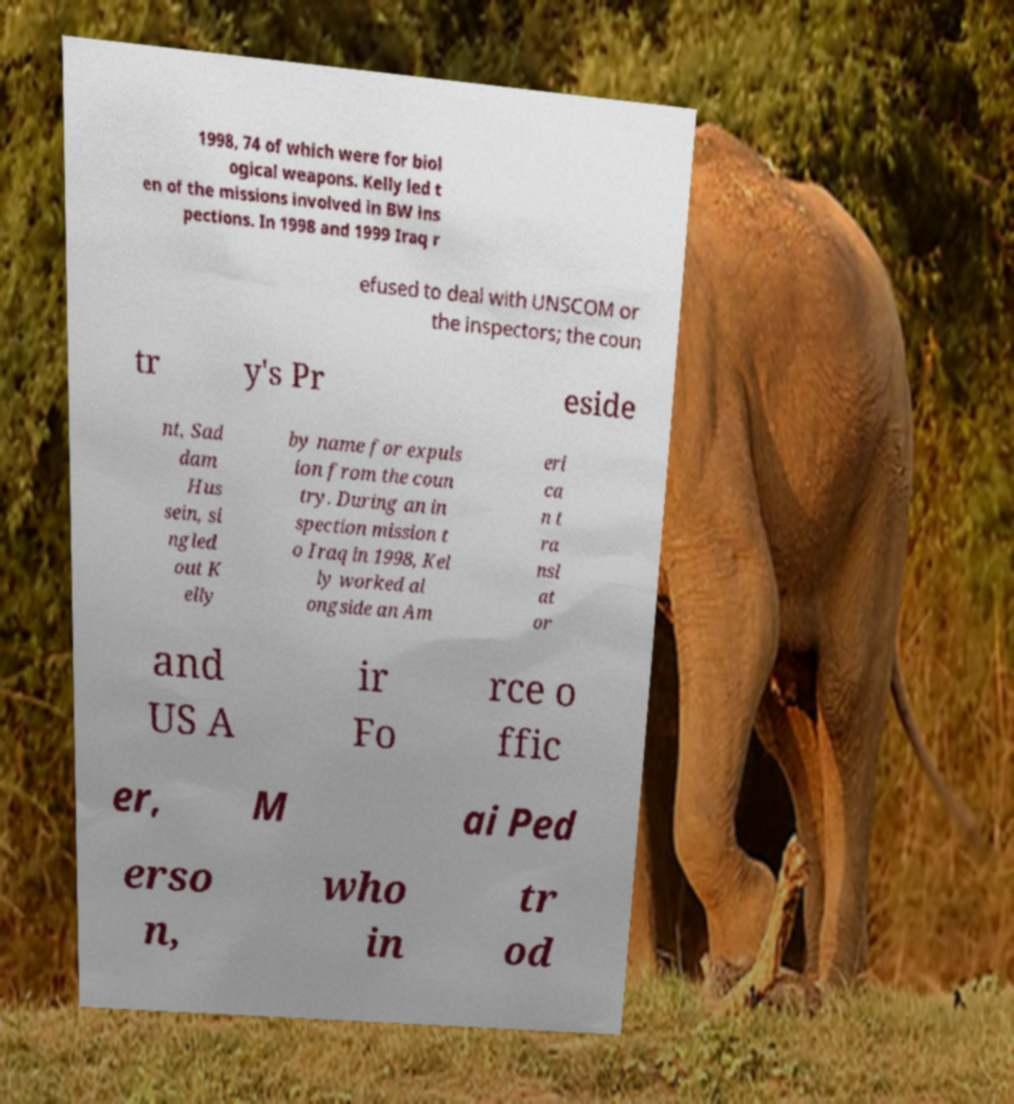For documentation purposes, I need the text within this image transcribed. Could you provide that? 1998, 74 of which were for biol ogical weapons. Kelly led t en of the missions involved in BW ins pections. In 1998 and 1999 Iraq r efused to deal with UNSCOM or the inspectors; the coun tr y's Pr eside nt, Sad dam Hus sein, si ngled out K elly by name for expuls ion from the coun try. During an in spection mission t o Iraq in 1998, Kel ly worked al ongside an Am eri ca n t ra nsl at or and US A ir Fo rce o ffic er, M ai Ped erso n, who in tr od 